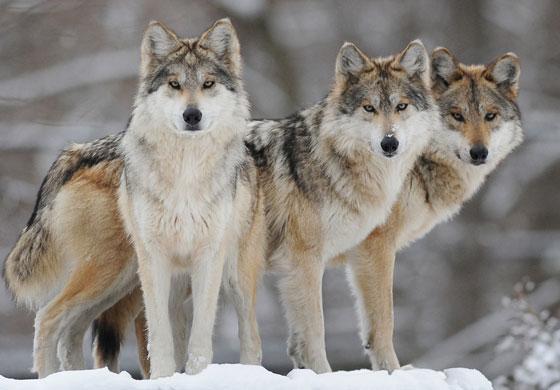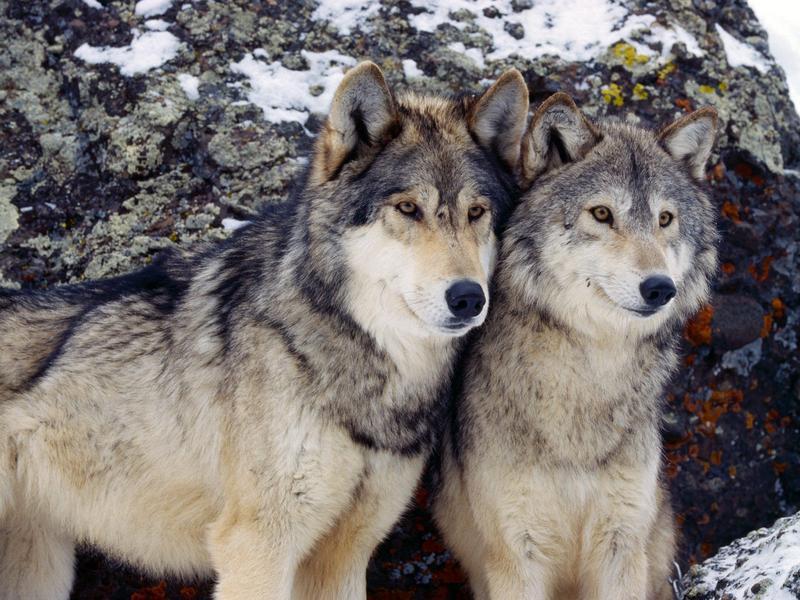The first image is the image on the left, the second image is the image on the right. For the images displayed, is the sentence "There are at least three wolves standing in the snow." factually correct? Answer yes or no. Yes. 